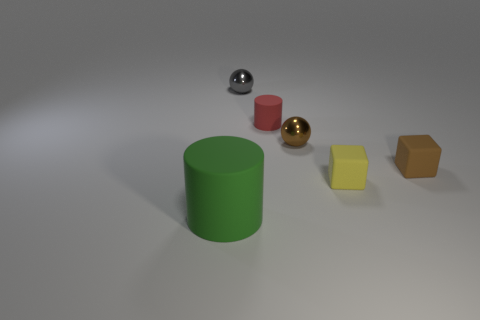Add 1 tiny yellow shiny objects. How many objects exist? 7 Subtract all cylinders. How many objects are left? 4 Add 1 big gray matte cylinders. How many big gray matte cylinders exist? 1 Subtract 1 gray spheres. How many objects are left? 5 Subtract all green rubber blocks. Subtract all small brown blocks. How many objects are left? 5 Add 4 big green things. How many big green things are left? 5 